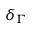Convert formula to latex. <formula><loc_0><loc_0><loc_500><loc_500>\delta _ { \Gamma }</formula> 